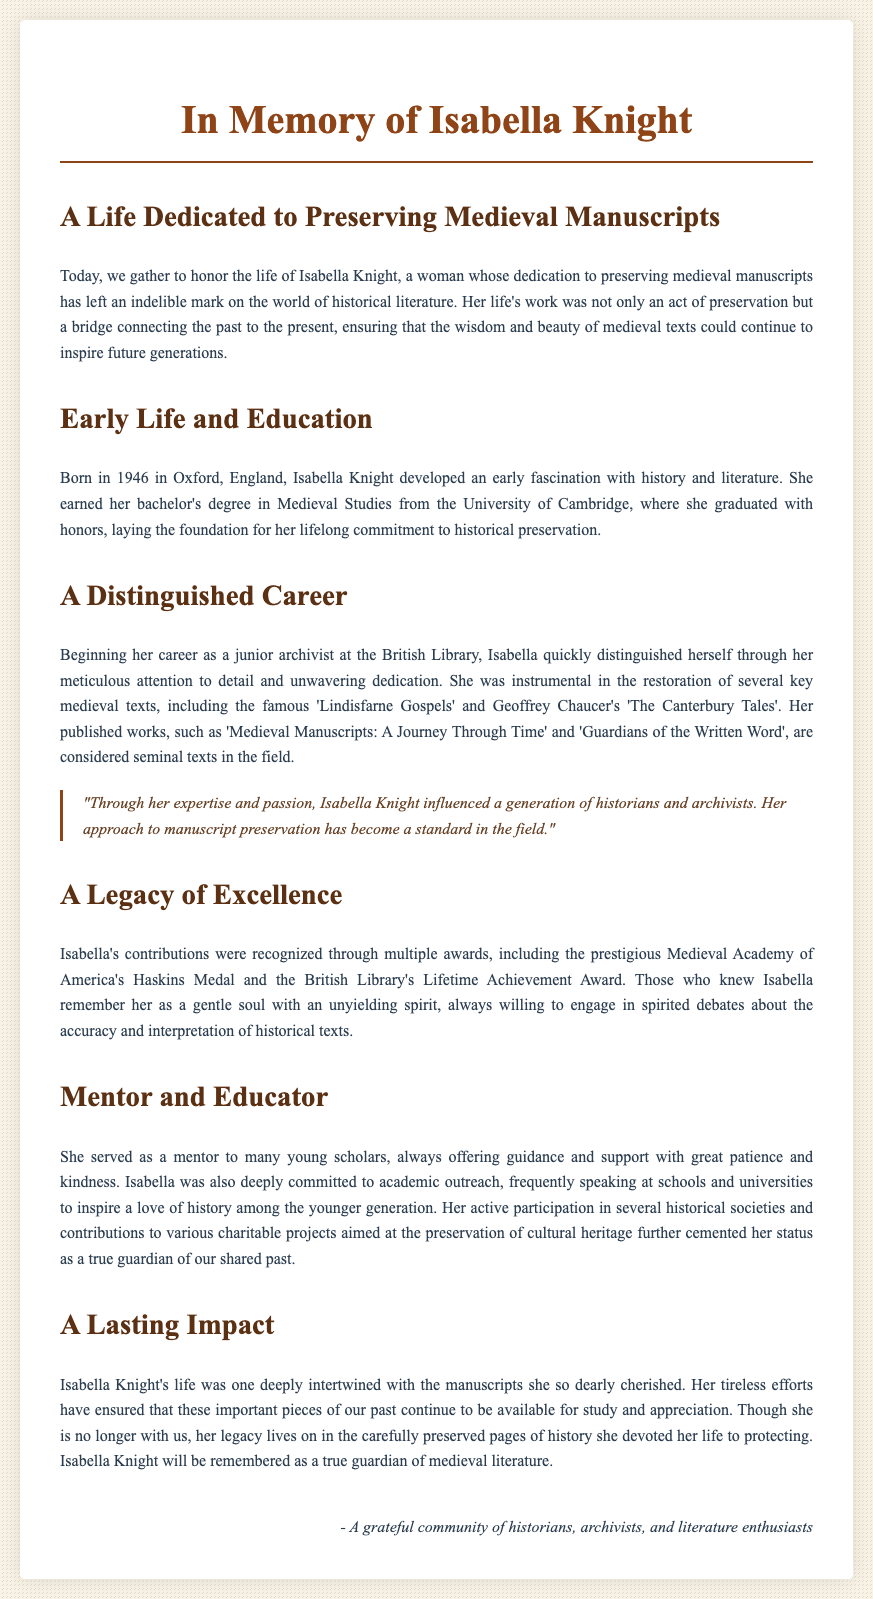What year was Isabella Knight born? The document states that Isabella Knight was born in 1946.
Answer: 1946 Where did Isabella Knight earn her bachelor's degree? The text mentions that she earned her degree from the University of Cambridge.
Answer: University of Cambridge What prestigious award did Isabella receive from the Medieval Academy of America? The document specifies she received the Haskins Medal.
Answer: Haskins Medal What was one of Isabella's notable publications? The text lists 'Medieval Manuscripts: A Journey Through Time' as a notable work.
Answer: Medieval Manuscripts: A Journey Through Time How did Isabella Knight influence future historians? The document states that her expertise and passion influenced a generation of historians and archivists.
Answer: Influenced a generation of historians and archivists What role did Isabella Knight play in academic outreach? It states she spoke at schools and universities to inspire a love of history.
Answer: Inspire a love of history Who regarded Isabella Knight as a gentle soul with an unyielding spirit? The text notes that those who knew her remember her this way.
Answer: Those who knew her What is the main theme of the eulogy? The main theme centers around Isabella's dedication to preserving medieval manuscripts.
Answer: Preserving medieval manuscripts 